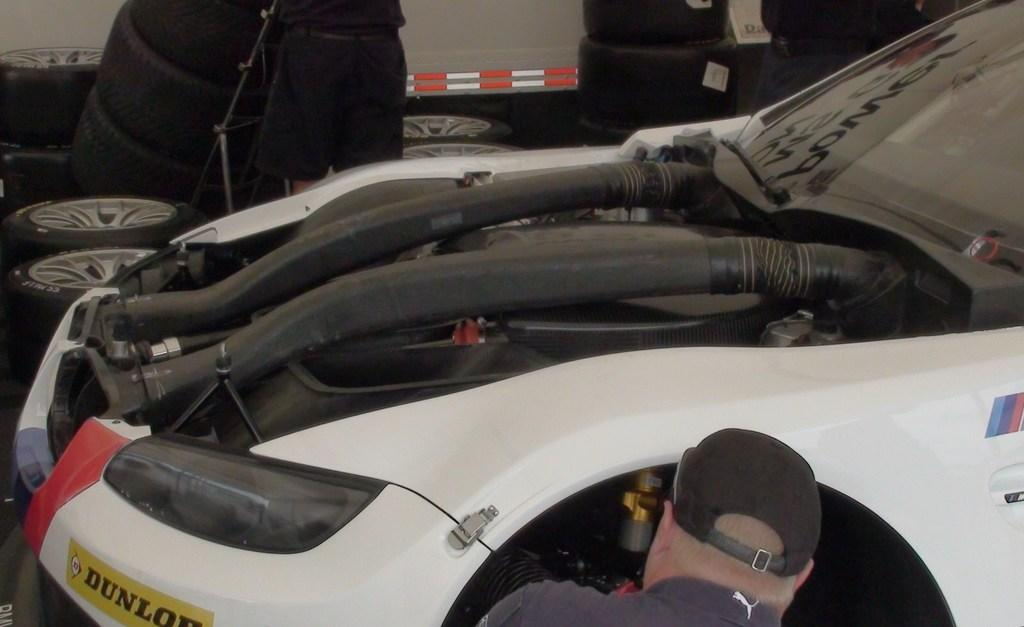What is the main subject of the image? There is a vehicle in the image. What parts of the vehicle can be seen in the image? There are tires and rods visible in the image. What else is present in the image besides the vehicle? There is a board and people in the image. What type of selection can be made from the tub in the image? There is no tub present in the image, so no selection can be made from it. 